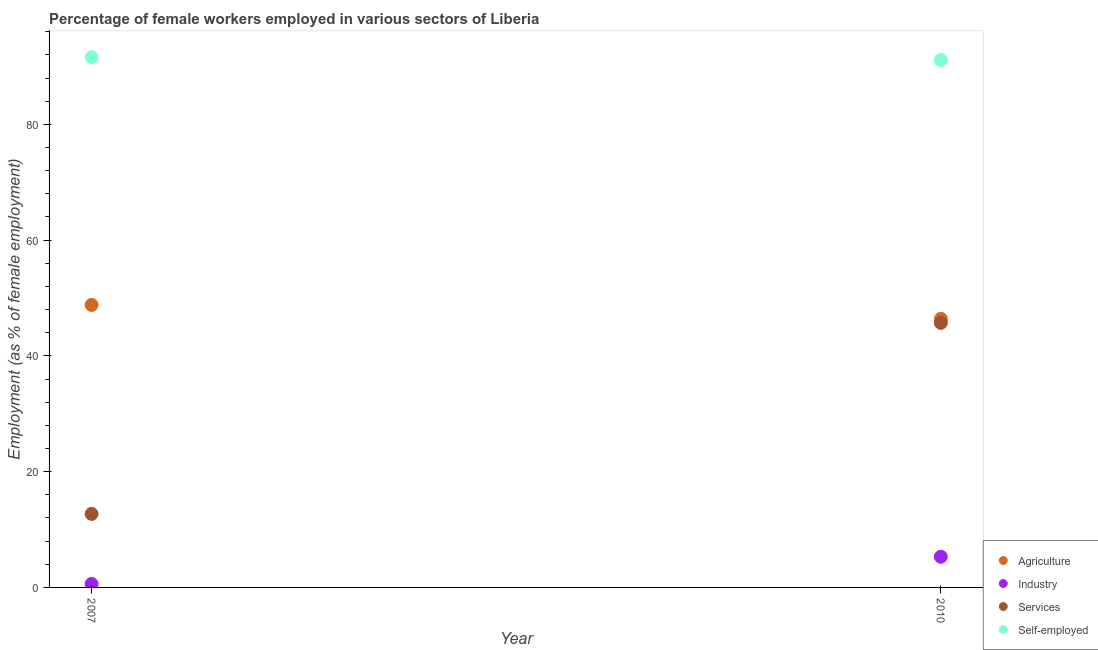What is the percentage of female workers in services in 2010?
Offer a terse response. 45.7. Across all years, what is the maximum percentage of female workers in industry?
Your answer should be very brief. 5.3. Across all years, what is the minimum percentage of self employed female workers?
Your answer should be very brief. 91.1. In which year was the percentage of female workers in agriculture maximum?
Ensure brevity in your answer.  2007. What is the total percentage of female workers in services in the graph?
Provide a succinct answer. 58.4. What is the difference between the percentage of female workers in agriculture in 2007 and that in 2010?
Ensure brevity in your answer.  2.4. What is the difference between the percentage of female workers in agriculture in 2007 and the percentage of female workers in services in 2010?
Offer a terse response. 3.1. What is the average percentage of self employed female workers per year?
Your answer should be very brief. 91.35. In the year 2010, what is the difference between the percentage of female workers in industry and percentage of self employed female workers?
Offer a terse response. -85.8. What is the ratio of the percentage of self employed female workers in 2007 to that in 2010?
Your answer should be compact. 1.01. In how many years, is the percentage of female workers in services greater than the average percentage of female workers in services taken over all years?
Offer a very short reply. 1. Is it the case that in every year, the sum of the percentage of female workers in agriculture and percentage of female workers in industry is greater than the percentage of female workers in services?
Give a very brief answer. Yes. Does the percentage of female workers in agriculture monotonically increase over the years?
Ensure brevity in your answer.  No. Is the percentage of female workers in agriculture strictly greater than the percentage of self employed female workers over the years?
Give a very brief answer. No. Is the percentage of self employed female workers strictly less than the percentage of female workers in services over the years?
Make the answer very short. No. How many years are there in the graph?
Offer a very short reply. 2. Does the graph contain grids?
Offer a terse response. No. How many legend labels are there?
Provide a succinct answer. 4. What is the title of the graph?
Ensure brevity in your answer.  Percentage of female workers employed in various sectors of Liberia. What is the label or title of the Y-axis?
Keep it short and to the point. Employment (as % of female employment). What is the Employment (as % of female employment) in Agriculture in 2007?
Keep it short and to the point. 48.8. What is the Employment (as % of female employment) of Industry in 2007?
Your answer should be compact. 0.6. What is the Employment (as % of female employment) of Services in 2007?
Your response must be concise. 12.7. What is the Employment (as % of female employment) of Self-employed in 2007?
Your answer should be compact. 91.6. What is the Employment (as % of female employment) of Agriculture in 2010?
Ensure brevity in your answer.  46.4. What is the Employment (as % of female employment) of Industry in 2010?
Make the answer very short. 5.3. What is the Employment (as % of female employment) in Services in 2010?
Your answer should be very brief. 45.7. What is the Employment (as % of female employment) in Self-employed in 2010?
Keep it short and to the point. 91.1. Across all years, what is the maximum Employment (as % of female employment) of Agriculture?
Offer a very short reply. 48.8. Across all years, what is the maximum Employment (as % of female employment) in Industry?
Provide a short and direct response. 5.3. Across all years, what is the maximum Employment (as % of female employment) in Services?
Provide a succinct answer. 45.7. Across all years, what is the maximum Employment (as % of female employment) of Self-employed?
Your response must be concise. 91.6. Across all years, what is the minimum Employment (as % of female employment) in Agriculture?
Your answer should be compact. 46.4. Across all years, what is the minimum Employment (as % of female employment) of Industry?
Provide a short and direct response. 0.6. Across all years, what is the minimum Employment (as % of female employment) in Services?
Keep it short and to the point. 12.7. Across all years, what is the minimum Employment (as % of female employment) in Self-employed?
Your answer should be very brief. 91.1. What is the total Employment (as % of female employment) of Agriculture in the graph?
Make the answer very short. 95.2. What is the total Employment (as % of female employment) in Industry in the graph?
Provide a succinct answer. 5.9. What is the total Employment (as % of female employment) in Services in the graph?
Keep it short and to the point. 58.4. What is the total Employment (as % of female employment) in Self-employed in the graph?
Ensure brevity in your answer.  182.7. What is the difference between the Employment (as % of female employment) in Services in 2007 and that in 2010?
Your answer should be very brief. -33. What is the difference between the Employment (as % of female employment) of Self-employed in 2007 and that in 2010?
Your answer should be very brief. 0.5. What is the difference between the Employment (as % of female employment) of Agriculture in 2007 and the Employment (as % of female employment) of Industry in 2010?
Keep it short and to the point. 43.5. What is the difference between the Employment (as % of female employment) of Agriculture in 2007 and the Employment (as % of female employment) of Self-employed in 2010?
Make the answer very short. -42.3. What is the difference between the Employment (as % of female employment) in Industry in 2007 and the Employment (as % of female employment) in Services in 2010?
Make the answer very short. -45.1. What is the difference between the Employment (as % of female employment) in Industry in 2007 and the Employment (as % of female employment) in Self-employed in 2010?
Provide a succinct answer. -90.5. What is the difference between the Employment (as % of female employment) in Services in 2007 and the Employment (as % of female employment) in Self-employed in 2010?
Ensure brevity in your answer.  -78.4. What is the average Employment (as % of female employment) in Agriculture per year?
Make the answer very short. 47.6. What is the average Employment (as % of female employment) of Industry per year?
Keep it short and to the point. 2.95. What is the average Employment (as % of female employment) in Services per year?
Give a very brief answer. 29.2. What is the average Employment (as % of female employment) in Self-employed per year?
Your response must be concise. 91.35. In the year 2007, what is the difference between the Employment (as % of female employment) in Agriculture and Employment (as % of female employment) in Industry?
Offer a very short reply. 48.2. In the year 2007, what is the difference between the Employment (as % of female employment) in Agriculture and Employment (as % of female employment) in Services?
Provide a succinct answer. 36.1. In the year 2007, what is the difference between the Employment (as % of female employment) of Agriculture and Employment (as % of female employment) of Self-employed?
Your answer should be compact. -42.8. In the year 2007, what is the difference between the Employment (as % of female employment) of Industry and Employment (as % of female employment) of Services?
Your answer should be very brief. -12.1. In the year 2007, what is the difference between the Employment (as % of female employment) of Industry and Employment (as % of female employment) of Self-employed?
Give a very brief answer. -91. In the year 2007, what is the difference between the Employment (as % of female employment) of Services and Employment (as % of female employment) of Self-employed?
Offer a very short reply. -78.9. In the year 2010, what is the difference between the Employment (as % of female employment) of Agriculture and Employment (as % of female employment) of Industry?
Give a very brief answer. 41.1. In the year 2010, what is the difference between the Employment (as % of female employment) of Agriculture and Employment (as % of female employment) of Self-employed?
Offer a very short reply. -44.7. In the year 2010, what is the difference between the Employment (as % of female employment) of Industry and Employment (as % of female employment) of Services?
Keep it short and to the point. -40.4. In the year 2010, what is the difference between the Employment (as % of female employment) in Industry and Employment (as % of female employment) in Self-employed?
Your answer should be compact. -85.8. In the year 2010, what is the difference between the Employment (as % of female employment) of Services and Employment (as % of female employment) of Self-employed?
Offer a very short reply. -45.4. What is the ratio of the Employment (as % of female employment) in Agriculture in 2007 to that in 2010?
Your answer should be very brief. 1.05. What is the ratio of the Employment (as % of female employment) in Industry in 2007 to that in 2010?
Your answer should be compact. 0.11. What is the ratio of the Employment (as % of female employment) in Services in 2007 to that in 2010?
Offer a terse response. 0.28. What is the difference between the highest and the second highest Employment (as % of female employment) in Services?
Ensure brevity in your answer.  33. What is the difference between the highest and the lowest Employment (as % of female employment) of Industry?
Keep it short and to the point. 4.7. What is the difference between the highest and the lowest Employment (as % of female employment) in Self-employed?
Make the answer very short. 0.5. 